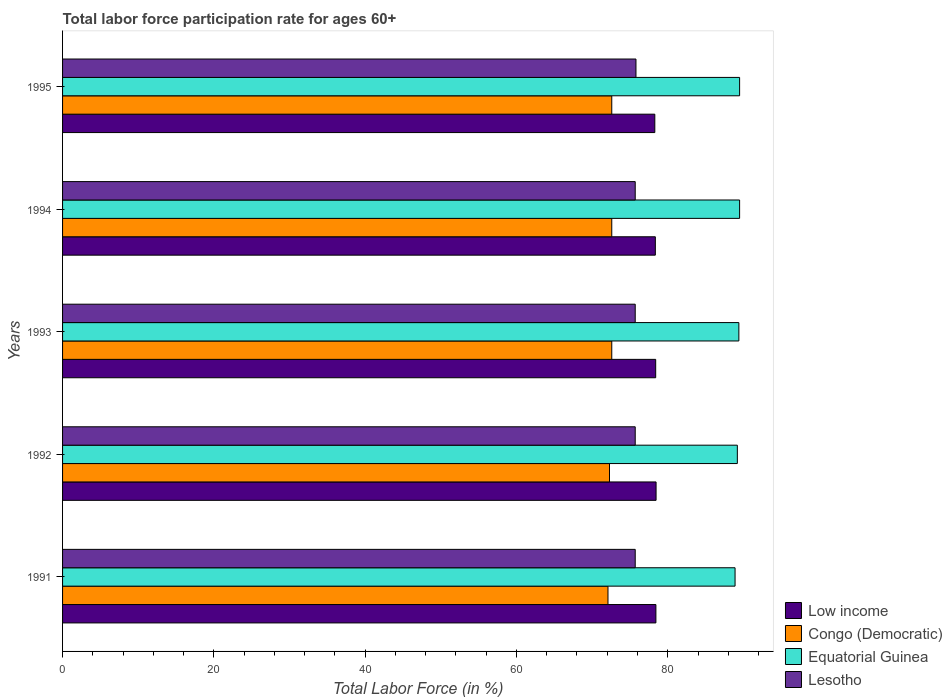Are the number of bars on each tick of the Y-axis equal?
Make the answer very short. Yes. How many bars are there on the 1st tick from the bottom?
Your answer should be very brief. 4. What is the label of the 3rd group of bars from the top?
Keep it short and to the point. 1993. In how many cases, is the number of bars for a given year not equal to the number of legend labels?
Your response must be concise. 0. What is the labor force participation rate in Congo (Democratic) in 1991?
Offer a very short reply. 72.1. Across all years, what is the maximum labor force participation rate in Low income?
Ensure brevity in your answer.  78.46. Across all years, what is the minimum labor force participation rate in Low income?
Provide a short and direct response. 78.29. What is the total labor force participation rate in Lesotho in the graph?
Offer a terse response. 378.6. What is the difference between the labor force participation rate in Equatorial Guinea in 1991 and the labor force participation rate in Congo (Democratic) in 1995?
Provide a succinct answer. 16.3. What is the average labor force participation rate in Lesotho per year?
Give a very brief answer. 75.72. In the year 1994, what is the difference between the labor force participation rate in Equatorial Guinea and labor force participation rate in Lesotho?
Offer a terse response. 13.8. What is the ratio of the labor force participation rate in Low income in 1991 to that in 1994?
Your response must be concise. 1. What is the difference between the highest and the second highest labor force participation rate in Low income?
Offer a very short reply. 0.02. What is the difference between the highest and the lowest labor force participation rate in Low income?
Your answer should be very brief. 0.17. In how many years, is the labor force participation rate in Lesotho greater than the average labor force participation rate in Lesotho taken over all years?
Offer a very short reply. 1. Is the sum of the labor force participation rate in Lesotho in 1993 and 1994 greater than the maximum labor force participation rate in Low income across all years?
Provide a short and direct response. Yes. Is it the case that in every year, the sum of the labor force participation rate in Congo (Democratic) and labor force participation rate in Lesotho is greater than the sum of labor force participation rate in Equatorial Guinea and labor force participation rate in Low income?
Provide a succinct answer. No. What does the 2nd bar from the top in 1991 represents?
Give a very brief answer. Equatorial Guinea. What does the 3rd bar from the bottom in 1994 represents?
Make the answer very short. Equatorial Guinea. Is it the case that in every year, the sum of the labor force participation rate in Equatorial Guinea and labor force participation rate in Low income is greater than the labor force participation rate in Congo (Democratic)?
Make the answer very short. Yes. Are all the bars in the graph horizontal?
Offer a very short reply. Yes. What is the title of the graph?
Your answer should be compact. Total labor force participation rate for ages 60+. What is the label or title of the X-axis?
Provide a succinct answer. Total Labor Force (in %). What is the label or title of the Y-axis?
Your answer should be compact. Years. What is the Total Labor Force (in %) of Low income in 1991?
Provide a short and direct response. 78.44. What is the Total Labor Force (in %) of Congo (Democratic) in 1991?
Offer a terse response. 72.1. What is the Total Labor Force (in %) in Equatorial Guinea in 1991?
Your answer should be compact. 88.9. What is the Total Labor Force (in %) of Lesotho in 1991?
Make the answer very short. 75.7. What is the Total Labor Force (in %) in Low income in 1992?
Offer a very short reply. 78.46. What is the Total Labor Force (in %) of Congo (Democratic) in 1992?
Your answer should be very brief. 72.3. What is the Total Labor Force (in %) of Equatorial Guinea in 1992?
Your answer should be compact. 89.2. What is the Total Labor Force (in %) in Lesotho in 1992?
Make the answer very short. 75.7. What is the Total Labor Force (in %) of Low income in 1993?
Provide a succinct answer. 78.41. What is the Total Labor Force (in %) of Congo (Democratic) in 1993?
Give a very brief answer. 72.6. What is the Total Labor Force (in %) in Equatorial Guinea in 1993?
Keep it short and to the point. 89.4. What is the Total Labor Force (in %) in Lesotho in 1993?
Provide a succinct answer. 75.7. What is the Total Labor Force (in %) of Low income in 1994?
Ensure brevity in your answer.  78.36. What is the Total Labor Force (in %) of Congo (Democratic) in 1994?
Provide a short and direct response. 72.6. What is the Total Labor Force (in %) of Equatorial Guinea in 1994?
Provide a short and direct response. 89.5. What is the Total Labor Force (in %) of Lesotho in 1994?
Make the answer very short. 75.7. What is the Total Labor Force (in %) of Low income in 1995?
Offer a very short reply. 78.29. What is the Total Labor Force (in %) of Congo (Democratic) in 1995?
Provide a short and direct response. 72.6. What is the Total Labor Force (in %) of Equatorial Guinea in 1995?
Keep it short and to the point. 89.5. What is the Total Labor Force (in %) of Lesotho in 1995?
Give a very brief answer. 75.8. Across all years, what is the maximum Total Labor Force (in %) in Low income?
Provide a short and direct response. 78.46. Across all years, what is the maximum Total Labor Force (in %) in Congo (Democratic)?
Provide a succinct answer. 72.6. Across all years, what is the maximum Total Labor Force (in %) of Equatorial Guinea?
Provide a short and direct response. 89.5. Across all years, what is the maximum Total Labor Force (in %) in Lesotho?
Keep it short and to the point. 75.8. Across all years, what is the minimum Total Labor Force (in %) of Low income?
Make the answer very short. 78.29. Across all years, what is the minimum Total Labor Force (in %) in Congo (Democratic)?
Offer a very short reply. 72.1. Across all years, what is the minimum Total Labor Force (in %) of Equatorial Guinea?
Provide a succinct answer. 88.9. Across all years, what is the minimum Total Labor Force (in %) of Lesotho?
Make the answer very short. 75.7. What is the total Total Labor Force (in %) in Low income in the graph?
Your answer should be compact. 391.95. What is the total Total Labor Force (in %) in Congo (Democratic) in the graph?
Offer a very short reply. 362.2. What is the total Total Labor Force (in %) in Equatorial Guinea in the graph?
Offer a terse response. 446.5. What is the total Total Labor Force (in %) in Lesotho in the graph?
Keep it short and to the point. 378.6. What is the difference between the Total Labor Force (in %) in Low income in 1991 and that in 1992?
Keep it short and to the point. -0.02. What is the difference between the Total Labor Force (in %) in Equatorial Guinea in 1991 and that in 1992?
Offer a very short reply. -0.3. What is the difference between the Total Labor Force (in %) in Lesotho in 1991 and that in 1992?
Provide a short and direct response. 0. What is the difference between the Total Labor Force (in %) in Low income in 1991 and that in 1993?
Provide a short and direct response. 0.03. What is the difference between the Total Labor Force (in %) of Congo (Democratic) in 1991 and that in 1993?
Offer a terse response. -0.5. What is the difference between the Total Labor Force (in %) in Low income in 1991 and that in 1994?
Keep it short and to the point. 0.08. What is the difference between the Total Labor Force (in %) in Congo (Democratic) in 1991 and that in 1994?
Provide a succinct answer. -0.5. What is the difference between the Total Labor Force (in %) of Low income in 1991 and that in 1995?
Keep it short and to the point. 0.15. What is the difference between the Total Labor Force (in %) in Equatorial Guinea in 1991 and that in 1995?
Offer a terse response. -0.6. What is the difference between the Total Labor Force (in %) in Low income in 1992 and that in 1993?
Offer a terse response. 0.05. What is the difference between the Total Labor Force (in %) of Congo (Democratic) in 1992 and that in 1993?
Offer a very short reply. -0.3. What is the difference between the Total Labor Force (in %) of Equatorial Guinea in 1992 and that in 1993?
Make the answer very short. -0.2. What is the difference between the Total Labor Force (in %) of Low income in 1992 and that in 1994?
Make the answer very short. 0.1. What is the difference between the Total Labor Force (in %) in Equatorial Guinea in 1992 and that in 1994?
Give a very brief answer. -0.3. What is the difference between the Total Labor Force (in %) of Lesotho in 1992 and that in 1994?
Make the answer very short. 0. What is the difference between the Total Labor Force (in %) of Low income in 1992 and that in 1995?
Your response must be concise. 0.17. What is the difference between the Total Labor Force (in %) in Equatorial Guinea in 1992 and that in 1995?
Offer a terse response. -0.3. What is the difference between the Total Labor Force (in %) of Lesotho in 1992 and that in 1995?
Keep it short and to the point. -0.1. What is the difference between the Total Labor Force (in %) in Low income in 1993 and that in 1994?
Provide a short and direct response. 0.05. What is the difference between the Total Labor Force (in %) of Low income in 1993 and that in 1995?
Keep it short and to the point. 0.12. What is the difference between the Total Labor Force (in %) in Equatorial Guinea in 1993 and that in 1995?
Give a very brief answer. -0.1. What is the difference between the Total Labor Force (in %) in Lesotho in 1993 and that in 1995?
Your response must be concise. -0.1. What is the difference between the Total Labor Force (in %) of Low income in 1994 and that in 1995?
Your answer should be compact. 0.07. What is the difference between the Total Labor Force (in %) in Congo (Democratic) in 1994 and that in 1995?
Give a very brief answer. 0. What is the difference between the Total Labor Force (in %) in Lesotho in 1994 and that in 1995?
Provide a succinct answer. -0.1. What is the difference between the Total Labor Force (in %) in Low income in 1991 and the Total Labor Force (in %) in Congo (Democratic) in 1992?
Provide a short and direct response. 6.13. What is the difference between the Total Labor Force (in %) of Low income in 1991 and the Total Labor Force (in %) of Equatorial Guinea in 1992?
Offer a very short reply. -10.77. What is the difference between the Total Labor Force (in %) in Low income in 1991 and the Total Labor Force (in %) in Lesotho in 1992?
Provide a succinct answer. 2.73. What is the difference between the Total Labor Force (in %) of Congo (Democratic) in 1991 and the Total Labor Force (in %) of Equatorial Guinea in 1992?
Ensure brevity in your answer.  -17.1. What is the difference between the Total Labor Force (in %) of Low income in 1991 and the Total Labor Force (in %) of Congo (Democratic) in 1993?
Your answer should be very brief. 5.83. What is the difference between the Total Labor Force (in %) in Low income in 1991 and the Total Labor Force (in %) in Equatorial Guinea in 1993?
Your answer should be very brief. -10.96. What is the difference between the Total Labor Force (in %) of Low income in 1991 and the Total Labor Force (in %) of Lesotho in 1993?
Make the answer very short. 2.73. What is the difference between the Total Labor Force (in %) in Congo (Democratic) in 1991 and the Total Labor Force (in %) in Equatorial Guinea in 1993?
Give a very brief answer. -17.3. What is the difference between the Total Labor Force (in %) in Low income in 1991 and the Total Labor Force (in %) in Congo (Democratic) in 1994?
Your answer should be compact. 5.83. What is the difference between the Total Labor Force (in %) in Low income in 1991 and the Total Labor Force (in %) in Equatorial Guinea in 1994?
Ensure brevity in your answer.  -11.06. What is the difference between the Total Labor Force (in %) of Low income in 1991 and the Total Labor Force (in %) of Lesotho in 1994?
Your response must be concise. 2.73. What is the difference between the Total Labor Force (in %) of Congo (Democratic) in 1991 and the Total Labor Force (in %) of Equatorial Guinea in 1994?
Provide a short and direct response. -17.4. What is the difference between the Total Labor Force (in %) of Congo (Democratic) in 1991 and the Total Labor Force (in %) of Lesotho in 1994?
Your response must be concise. -3.6. What is the difference between the Total Labor Force (in %) of Low income in 1991 and the Total Labor Force (in %) of Congo (Democratic) in 1995?
Your answer should be compact. 5.83. What is the difference between the Total Labor Force (in %) of Low income in 1991 and the Total Labor Force (in %) of Equatorial Guinea in 1995?
Make the answer very short. -11.06. What is the difference between the Total Labor Force (in %) in Low income in 1991 and the Total Labor Force (in %) in Lesotho in 1995?
Your response must be concise. 2.63. What is the difference between the Total Labor Force (in %) of Congo (Democratic) in 1991 and the Total Labor Force (in %) of Equatorial Guinea in 1995?
Keep it short and to the point. -17.4. What is the difference between the Total Labor Force (in %) in Congo (Democratic) in 1991 and the Total Labor Force (in %) in Lesotho in 1995?
Make the answer very short. -3.7. What is the difference between the Total Labor Force (in %) of Low income in 1992 and the Total Labor Force (in %) of Congo (Democratic) in 1993?
Offer a very short reply. 5.86. What is the difference between the Total Labor Force (in %) in Low income in 1992 and the Total Labor Force (in %) in Equatorial Guinea in 1993?
Provide a short and direct response. -10.94. What is the difference between the Total Labor Force (in %) in Low income in 1992 and the Total Labor Force (in %) in Lesotho in 1993?
Your answer should be very brief. 2.76. What is the difference between the Total Labor Force (in %) of Congo (Democratic) in 1992 and the Total Labor Force (in %) of Equatorial Guinea in 1993?
Keep it short and to the point. -17.1. What is the difference between the Total Labor Force (in %) of Low income in 1992 and the Total Labor Force (in %) of Congo (Democratic) in 1994?
Ensure brevity in your answer.  5.86. What is the difference between the Total Labor Force (in %) in Low income in 1992 and the Total Labor Force (in %) in Equatorial Guinea in 1994?
Provide a succinct answer. -11.04. What is the difference between the Total Labor Force (in %) of Low income in 1992 and the Total Labor Force (in %) of Lesotho in 1994?
Your answer should be compact. 2.76. What is the difference between the Total Labor Force (in %) in Congo (Democratic) in 1992 and the Total Labor Force (in %) in Equatorial Guinea in 1994?
Offer a very short reply. -17.2. What is the difference between the Total Labor Force (in %) of Equatorial Guinea in 1992 and the Total Labor Force (in %) of Lesotho in 1994?
Offer a very short reply. 13.5. What is the difference between the Total Labor Force (in %) in Low income in 1992 and the Total Labor Force (in %) in Congo (Democratic) in 1995?
Ensure brevity in your answer.  5.86. What is the difference between the Total Labor Force (in %) of Low income in 1992 and the Total Labor Force (in %) of Equatorial Guinea in 1995?
Offer a terse response. -11.04. What is the difference between the Total Labor Force (in %) of Low income in 1992 and the Total Labor Force (in %) of Lesotho in 1995?
Offer a very short reply. 2.66. What is the difference between the Total Labor Force (in %) in Congo (Democratic) in 1992 and the Total Labor Force (in %) in Equatorial Guinea in 1995?
Keep it short and to the point. -17.2. What is the difference between the Total Labor Force (in %) in Equatorial Guinea in 1992 and the Total Labor Force (in %) in Lesotho in 1995?
Ensure brevity in your answer.  13.4. What is the difference between the Total Labor Force (in %) in Low income in 1993 and the Total Labor Force (in %) in Congo (Democratic) in 1994?
Keep it short and to the point. 5.81. What is the difference between the Total Labor Force (in %) of Low income in 1993 and the Total Labor Force (in %) of Equatorial Guinea in 1994?
Offer a very short reply. -11.09. What is the difference between the Total Labor Force (in %) of Low income in 1993 and the Total Labor Force (in %) of Lesotho in 1994?
Make the answer very short. 2.71. What is the difference between the Total Labor Force (in %) of Congo (Democratic) in 1993 and the Total Labor Force (in %) of Equatorial Guinea in 1994?
Your answer should be very brief. -16.9. What is the difference between the Total Labor Force (in %) in Congo (Democratic) in 1993 and the Total Labor Force (in %) in Lesotho in 1994?
Your answer should be very brief. -3.1. What is the difference between the Total Labor Force (in %) in Low income in 1993 and the Total Labor Force (in %) in Congo (Democratic) in 1995?
Make the answer very short. 5.81. What is the difference between the Total Labor Force (in %) in Low income in 1993 and the Total Labor Force (in %) in Equatorial Guinea in 1995?
Make the answer very short. -11.09. What is the difference between the Total Labor Force (in %) in Low income in 1993 and the Total Labor Force (in %) in Lesotho in 1995?
Keep it short and to the point. 2.61. What is the difference between the Total Labor Force (in %) in Congo (Democratic) in 1993 and the Total Labor Force (in %) in Equatorial Guinea in 1995?
Provide a short and direct response. -16.9. What is the difference between the Total Labor Force (in %) of Congo (Democratic) in 1993 and the Total Labor Force (in %) of Lesotho in 1995?
Your answer should be compact. -3.2. What is the difference between the Total Labor Force (in %) of Low income in 1994 and the Total Labor Force (in %) of Congo (Democratic) in 1995?
Offer a very short reply. 5.76. What is the difference between the Total Labor Force (in %) of Low income in 1994 and the Total Labor Force (in %) of Equatorial Guinea in 1995?
Provide a short and direct response. -11.14. What is the difference between the Total Labor Force (in %) in Low income in 1994 and the Total Labor Force (in %) in Lesotho in 1995?
Offer a terse response. 2.56. What is the difference between the Total Labor Force (in %) in Congo (Democratic) in 1994 and the Total Labor Force (in %) in Equatorial Guinea in 1995?
Provide a succinct answer. -16.9. What is the average Total Labor Force (in %) of Low income per year?
Give a very brief answer. 78.39. What is the average Total Labor Force (in %) in Congo (Democratic) per year?
Your answer should be compact. 72.44. What is the average Total Labor Force (in %) in Equatorial Guinea per year?
Give a very brief answer. 89.3. What is the average Total Labor Force (in %) in Lesotho per year?
Offer a very short reply. 75.72. In the year 1991, what is the difference between the Total Labor Force (in %) of Low income and Total Labor Force (in %) of Congo (Democratic)?
Your response must be concise. 6.33. In the year 1991, what is the difference between the Total Labor Force (in %) of Low income and Total Labor Force (in %) of Equatorial Guinea?
Ensure brevity in your answer.  -10.46. In the year 1991, what is the difference between the Total Labor Force (in %) of Low income and Total Labor Force (in %) of Lesotho?
Make the answer very short. 2.73. In the year 1991, what is the difference between the Total Labor Force (in %) in Congo (Democratic) and Total Labor Force (in %) in Equatorial Guinea?
Your answer should be compact. -16.8. In the year 1991, what is the difference between the Total Labor Force (in %) in Congo (Democratic) and Total Labor Force (in %) in Lesotho?
Your answer should be very brief. -3.6. In the year 1991, what is the difference between the Total Labor Force (in %) in Equatorial Guinea and Total Labor Force (in %) in Lesotho?
Offer a terse response. 13.2. In the year 1992, what is the difference between the Total Labor Force (in %) of Low income and Total Labor Force (in %) of Congo (Democratic)?
Make the answer very short. 6.16. In the year 1992, what is the difference between the Total Labor Force (in %) of Low income and Total Labor Force (in %) of Equatorial Guinea?
Make the answer very short. -10.74. In the year 1992, what is the difference between the Total Labor Force (in %) of Low income and Total Labor Force (in %) of Lesotho?
Your answer should be very brief. 2.76. In the year 1992, what is the difference between the Total Labor Force (in %) of Congo (Democratic) and Total Labor Force (in %) of Equatorial Guinea?
Your answer should be very brief. -16.9. In the year 1992, what is the difference between the Total Labor Force (in %) of Congo (Democratic) and Total Labor Force (in %) of Lesotho?
Your answer should be very brief. -3.4. In the year 1993, what is the difference between the Total Labor Force (in %) in Low income and Total Labor Force (in %) in Congo (Democratic)?
Provide a short and direct response. 5.81. In the year 1993, what is the difference between the Total Labor Force (in %) in Low income and Total Labor Force (in %) in Equatorial Guinea?
Ensure brevity in your answer.  -10.99. In the year 1993, what is the difference between the Total Labor Force (in %) of Low income and Total Labor Force (in %) of Lesotho?
Ensure brevity in your answer.  2.71. In the year 1993, what is the difference between the Total Labor Force (in %) in Congo (Democratic) and Total Labor Force (in %) in Equatorial Guinea?
Keep it short and to the point. -16.8. In the year 1993, what is the difference between the Total Labor Force (in %) in Congo (Democratic) and Total Labor Force (in %) in Lesotho?
Your response must be concise. -3.1. In the year 1993, what is the difference between the Total Labor Force (in %) of Equatorial Guinea and Total Labor Force (in %) of Lesotho?
Provide a succinct answer. 13.7. In the year 1994, what is the difference between the Total Labor Force (in %) in Low income and Total Labor Force (in %) in Congo (Democratic)?
Provide a succinct answer. 5.76. In the year 1994, what is the difference between the Total Labor Force (in %) in Low income and Total Labor Force (in %) in Equatorial Guinea?
Your answer should be compact. -11.14. In the year 1994, what is the difference between the Total Labor Force (in %) of Low income and Total Labor Force (in %) of Lesotho?
Provide a succinct answer. 2.66. In the year 1994, what is the difference between the Total Labor Force (in %) in Congo (Democratic) and Total Labor Force (in %) in Equatorial Guinea?
Your response must be concise. -16.9. In the year 1994, what is the difference between the Total Labor Force (in %) of Congo (Democratic) and Total Labor Force (in %) of Lesotho?
Make the answer very short. -3.1. In the year 1995, what is the difference between the Total Labor Force (in %) in Low income and Total Labor Force (in %) in Congo (Democratic)?
Offer a terse response. 5.69. In the year 1995, what is the difference between the Total Labor Force (in %) in Low income and Total Labor Force (in %) in Equatorial Guinea?
Your answer should be compact. -11.21. In the year 1995, what is the difference between the Total Labor Force (in %) of Low income and Total Labor Force (in %) of Lesotho?
Your answer should be very brief. 2.49. In the year 1995, what is the difference between the Total Labor Force (in %) of Congo (Democratic) and Total Labor Force (in %) of Equatorial Guinea?
Keep it short and to the point. -16.9. In the year 1995, what is the difference between the Total Labor Force (in %) in Equatorial Guinea and Total Labor Force (in %) in Lesotho?
Provide a succinct answer. 13.7. What is the ratio of the Total Labor Force (in %) of Congo (Democratic) in 1991 to that in 1992?
Your response must be concise. 1. What is the ratio of the Total Labor Force (in %) in Equatorial Guinea in 1991 to that in 1992?
Ensure brevity in your answer.  1. What is the ratio of the Total Labor Force (in %) of Lesotho in 1991 to that in 1993?
Offer a terse response. 1. What is the ratio of the Total Labor Force (in %) of Congo (Democratic) in 1991 to that in 1994?
Your answer should be compact. 0.99. What is the ratio of the Total Labor Force (in %) in Low income in 1991 to that in 1995?
Offer a terse response. 1. What is the ratio of the Total Labor Force (in %) in Equatorial Guinea in 1991 to that in 1995?
Keep it short and to the point. 0.99. What is the ratio of the Total Labor Force (in %) of Lesotho in 1991 to that in 1995?
Your response must be concise. 1. What is the ratio of the Total Labor Force (in %) of Low income in 1992 to that in 1993?
Your answer should be compact. 1. What is the ratio of the Total Labor Force (in %) in Congo (Democratic) in 1992 to that in 1993?
Your answer should be compact. 1. What is the ratio of the Total Labor Force (in %) of Equatorial Guinea in 1992 to that in 1993?
Keep it short and to the point. 1. What is the ratio of the Total Labor Force (in %) in Lesotho in 1992 to that in 1993?
Ensure brevity in your answer.  1. What is the ratio of the Total Labor Force (in %) of Congo (Democratic) in 1992 to that in 1994?
Ensure brevity in your answer.  1. What is the ratio of the Total Labor Force (in %) in Equatorial Guinea in 1992 to that in 1994?
Your answer should be very brief. 1. What is the ratio of the Total Labor Force (in %) in Congo (Democratic) in 1993 to that in 1994?
Offer a terse response. 1. What is the ratio of the Total Labor Force (in %) of Low income in 1993 to that in 1995?
Your response must be concise. 1. What is the ratio of the Total Labor Force (in %) of Congo (Democratic) in 1993 to that in 1995?
Offer a terse response. 1. What is the ratio of the Total Labor Force (in %) of Equatorial Guinea in 1993 to that in 1995?
Give a very brief answer. 1. What is the ratio of the Total Labor Force (in %) of Congo (Democratic) in 1994 to that in 1995?
Offer a terse response. 1. What is the ratio of the Total Labor Force (in %) of Lesotho in 1994 to that in 1995?
Give a very brief answer. 1. What is the difference between the highest and the second highest Total Labor Force (in %) in Low income?
Make the answer very short. 0.02. What is the difference between the highest and the second highest Total Labor Force (in %) in Congo (Democratic)?
Provide a succinct answer. 0. What is the difference between the highest and the lowest Total Labor Force (in %) of Low income?
Offer a terse response. 0.17. What is the difference between the highest and the lowest Total Labor Force (in %) in Lesotho?
Keep it short and to the point. 0.1. 